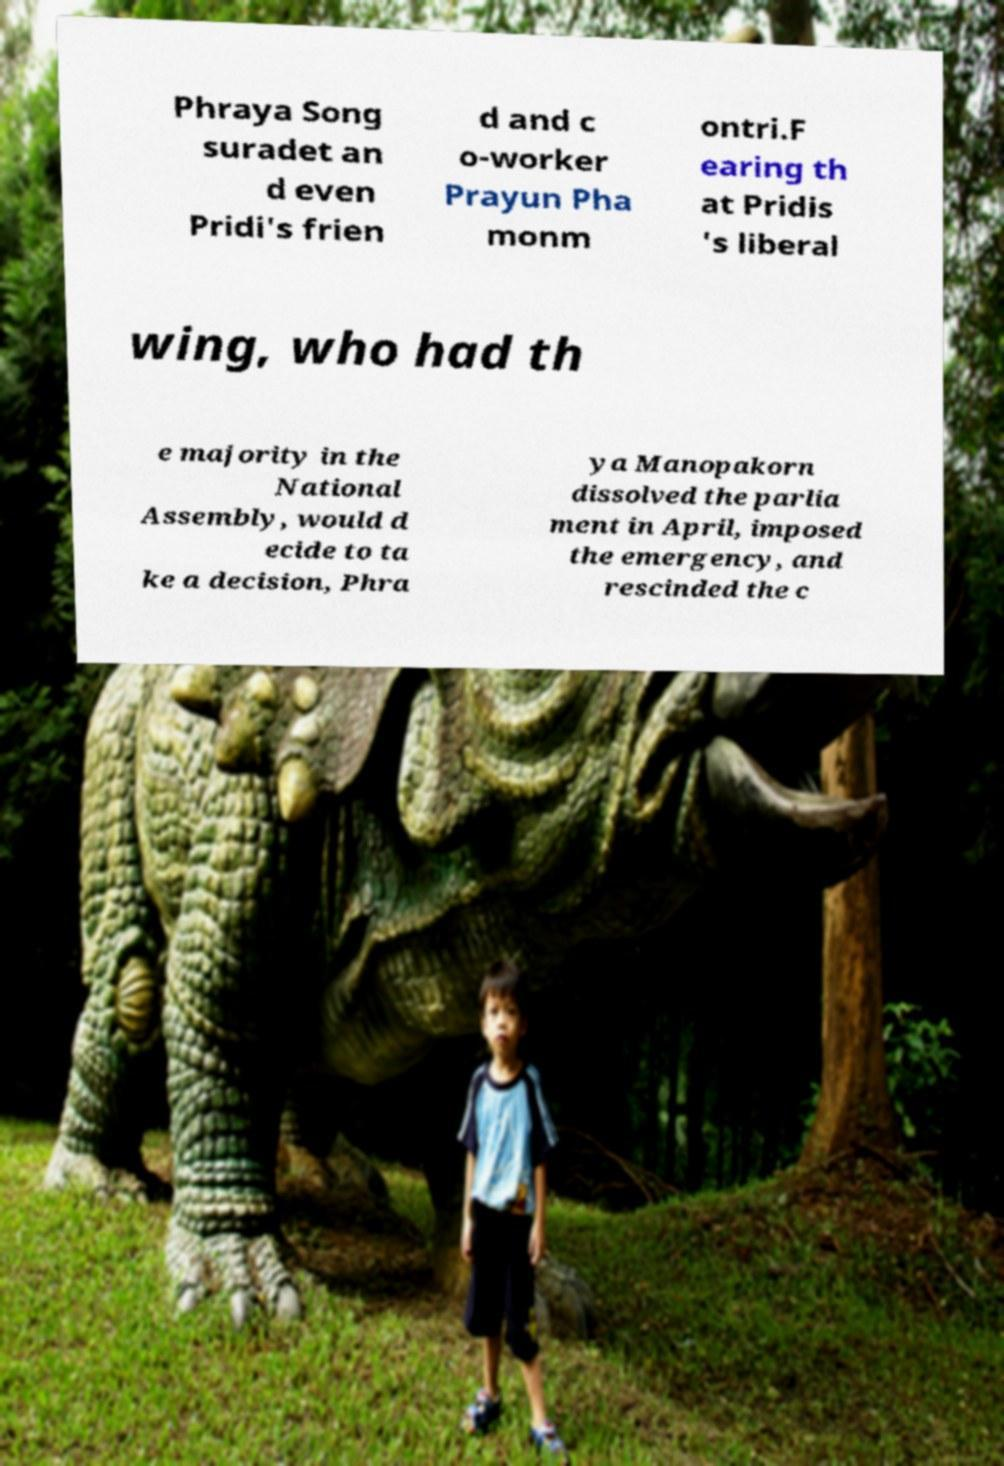Could you extract and type out the text from this image? Phraya Song suradet an d even Pridi's frien d and c o-worker Prayun Pha monm ontri.F earing th at Pridis 's liberal wing, who had th e majority in the National Assembly, would d ecide to ta ke a decision, Phra ya Manopakorn dissolved the parlia ment in April, imposed the emergency, and rescinded the c 